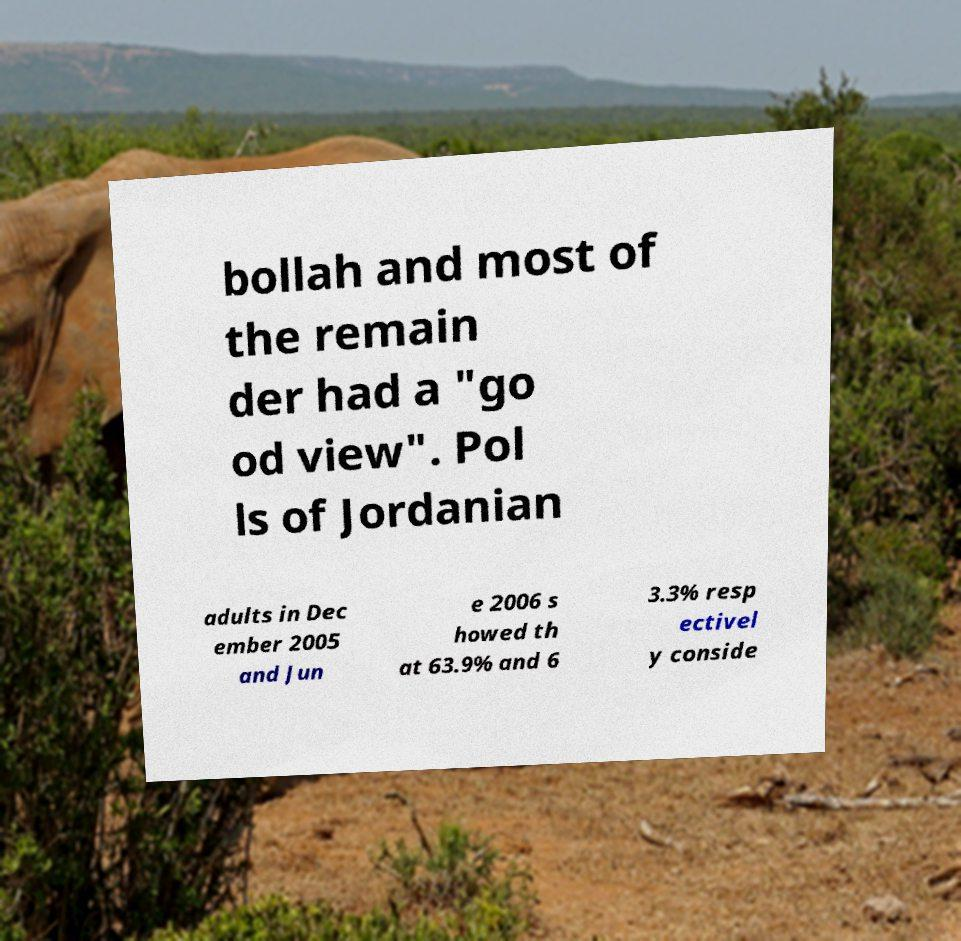I need the written content from this picture converted into text. Can you do that? bollah and most of the remain der had a "go od view". Pol ls of Jordanian adults in Dec ember 2005 and Jun e 2006 s howed th at 63.9% and 6 3.3% resp ectivel y conside 